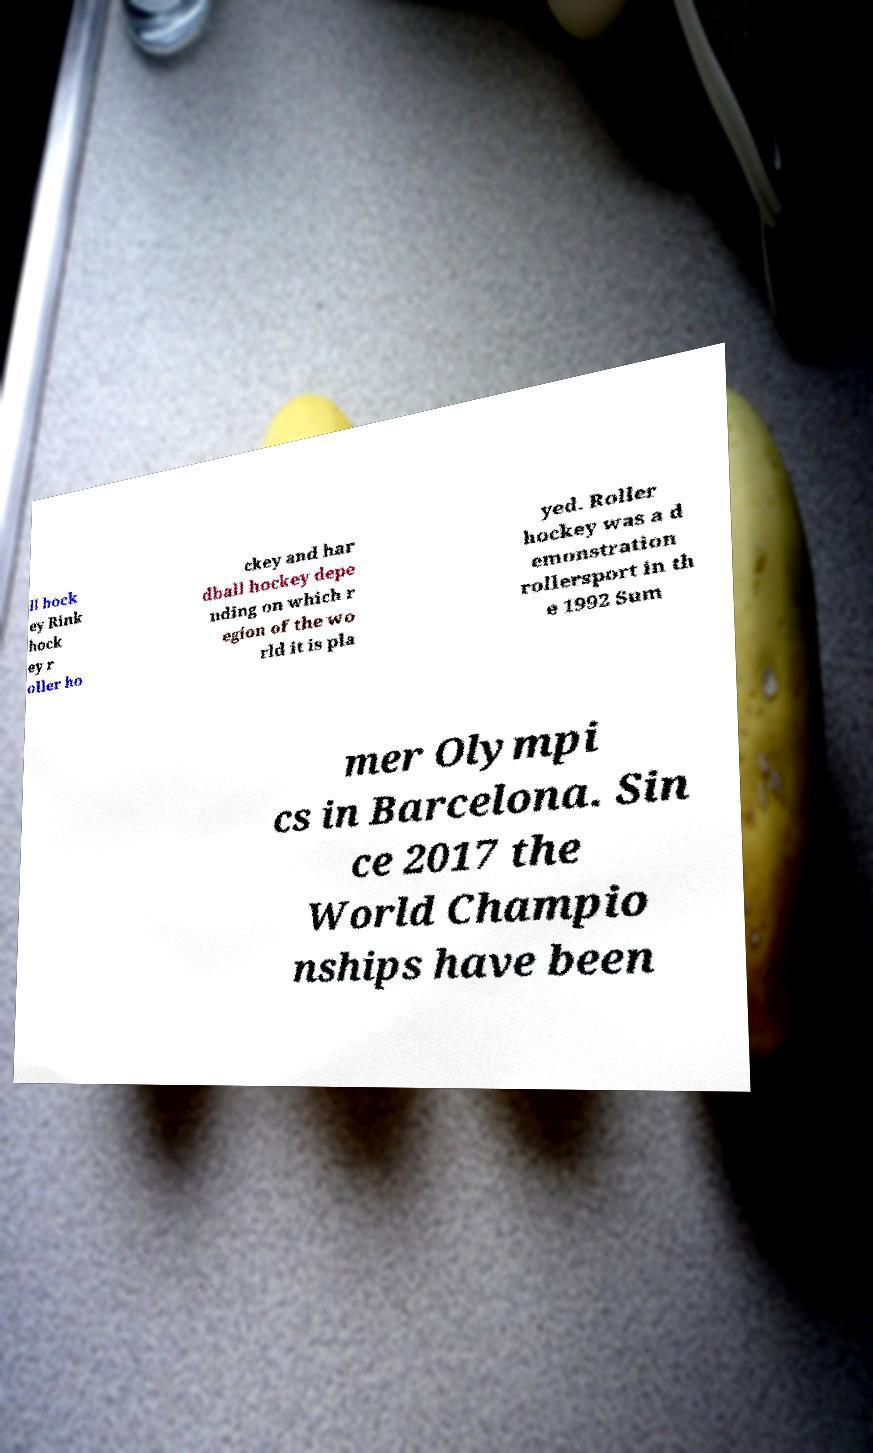Please identify and transcribe the text found in this image. ll hock ey Rink hock ey r oller ho ckey and har dball hockey depe nding on which r egion of the wo rld it is pla yed. Roller hockey was a d emonstration rollersport in th e 1992 Sum mer Olympi cs in Barcelona. Sin ce 2017 the World Champio nships have been 